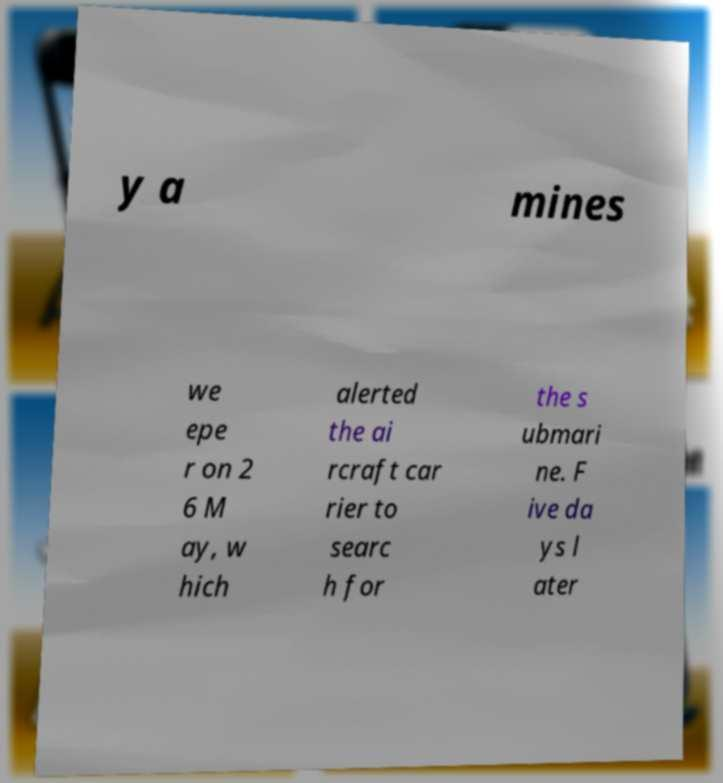Can you read and provide the text displayed in the image?This photo seems to have some interesting text. Can you extract and type it out for me? y a mines we epe r on 2 6 M ay, w hich alerted the ai rcraft car rier to searc h for the s ubmari ne. F ive da ys l ater 